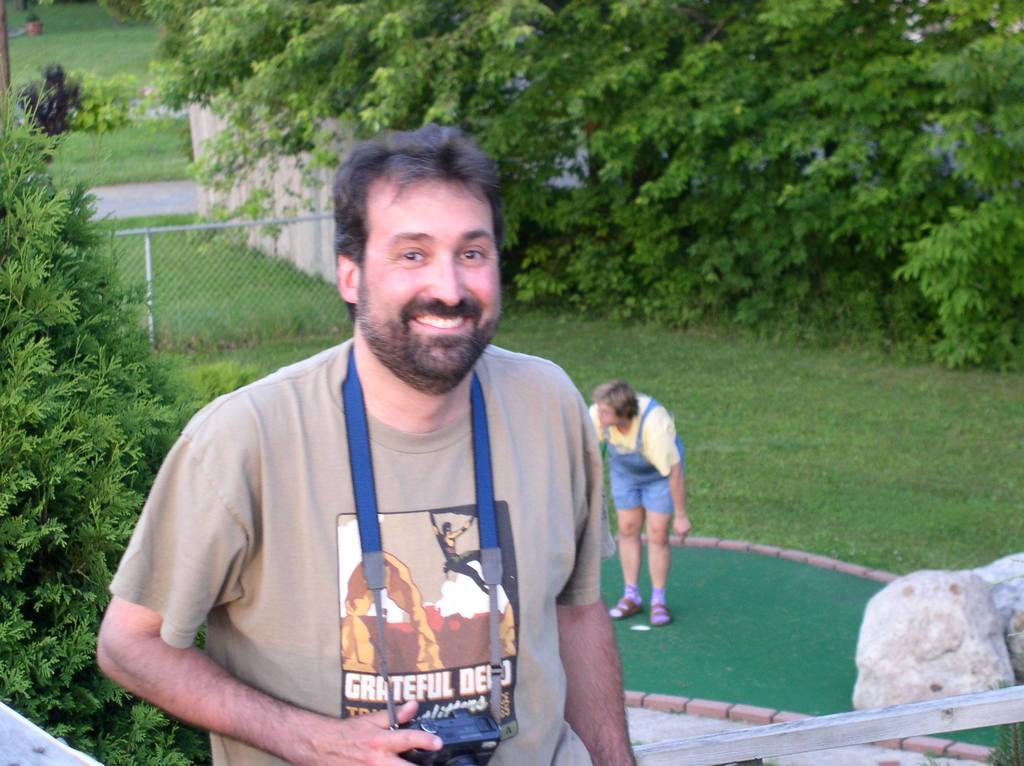Can you describe this image briefly? In this picture there is a man smiling and holding a camera and we can see rod, behind him there is a person and we can see tree, grass and rocks. In the background of the image we can see mesh, grass, trees and plants. 